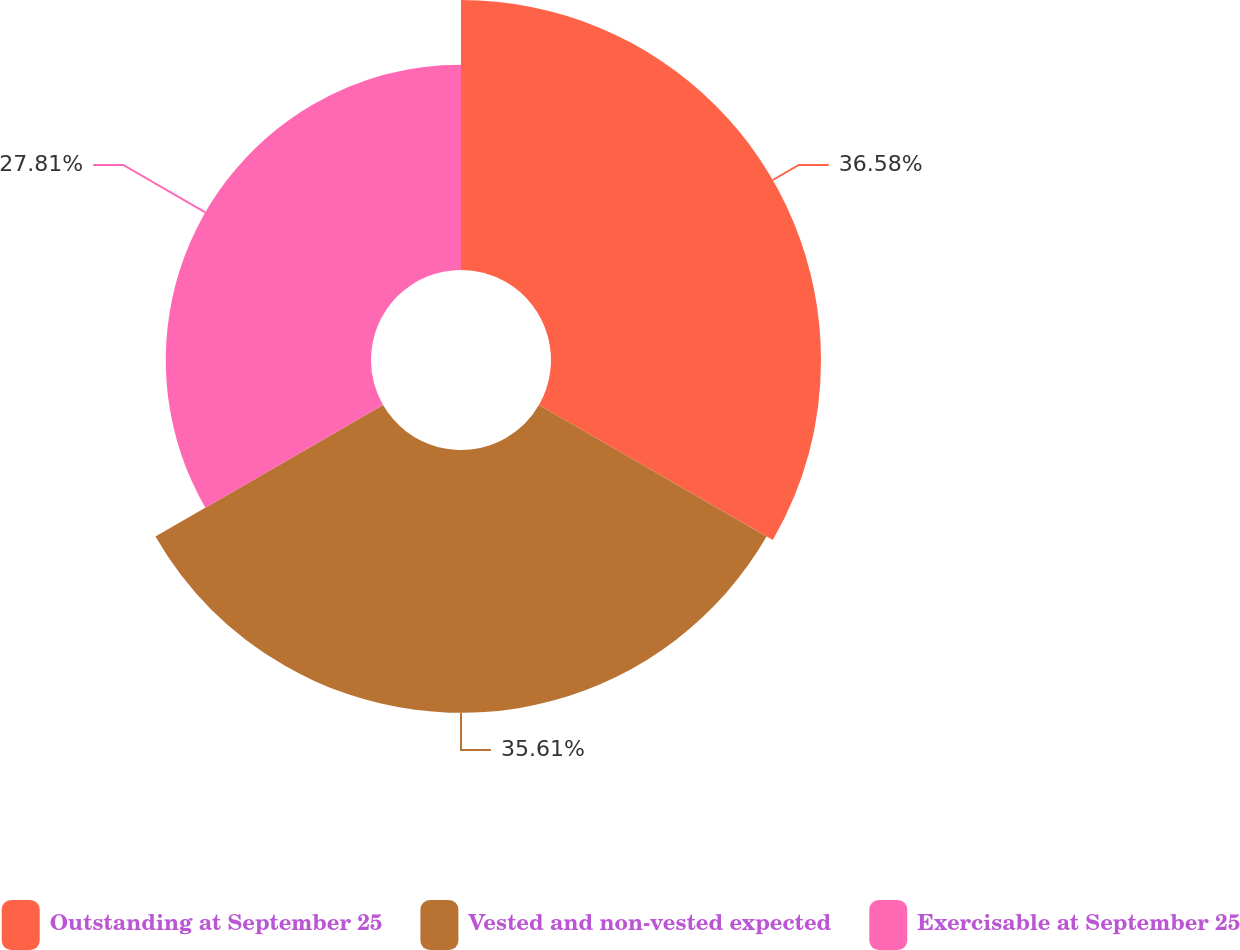Convert chart to OTSL. <chart><loc_0><loc_0><loc_500><loc_500><pie_chart><fcel>Outstanding at September 25<fcel>Vested and non-vested expected<fcel>Exercisable at September 25<nl><fcel>36.58%<fcel>35.61%<fcel>27.81%<nl></chart> 